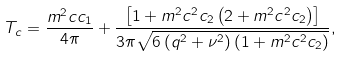<formula> <loc_0><loc_0><loc_500><loc_500>T _ { c } = \frac { m ^ { 2 } c c _ { 1 } } { 4 \pi } + \frac { \left [ 1 + m ^ { 2 } c ^ { 2 } c _ { 2 } \left ( 2 + m ^ { 2 } c ^ { 2 } c _ { 2 } \right ) \right ] } { 3 \pi \sqrt { 6 \left ( q ^ { 2 } + \nu ^ { 2 } \right ) \left ( 1 + m ^ { 2 } c ^ { 2 } c _ { 2 } \right ) } } ,</formula> 